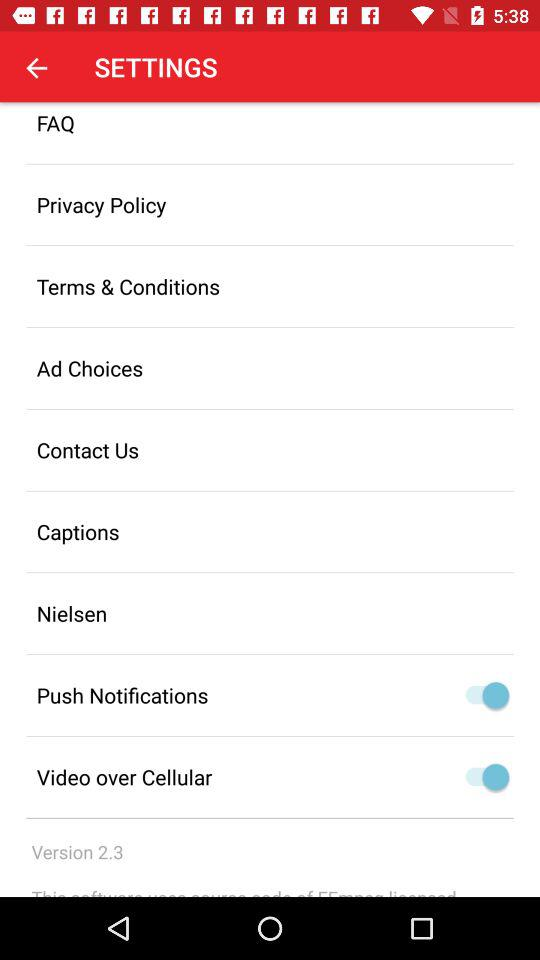What's the status of "Video over Cellular"? The status is "on". 